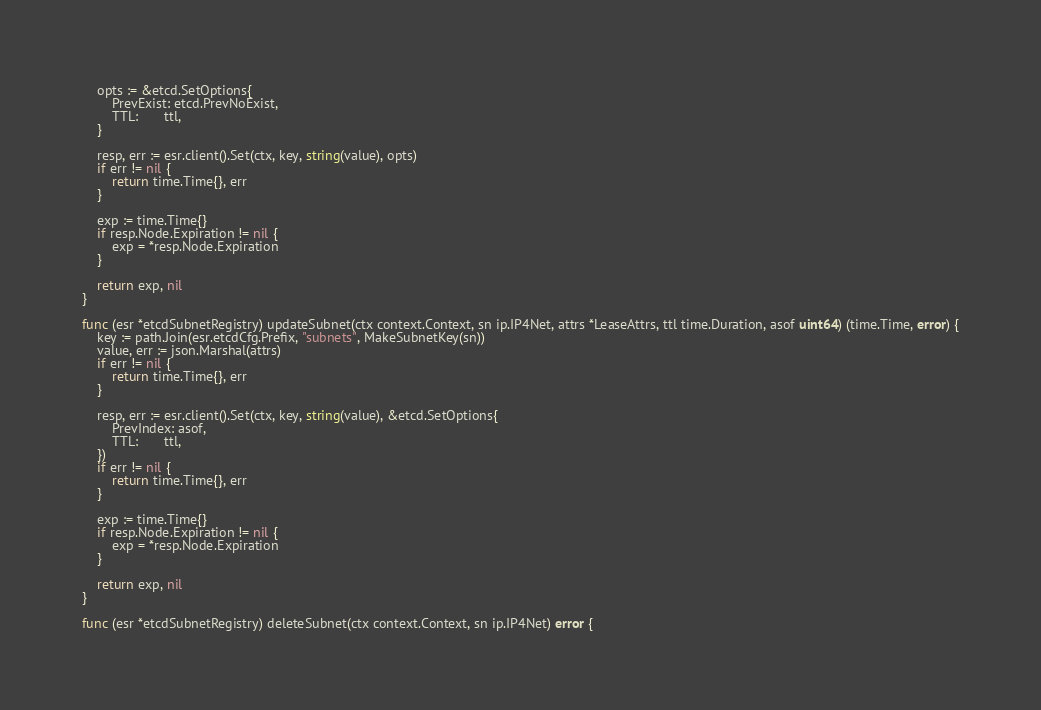<code> <loc_0><loc_0><loc_500><loc_500><_Go_>	opts := &etcd.SetOptions{
		PrevExist: etcd.PrevNoExist,
		TTL:       ttl,
	}

	resp, err := esr.client().Set(ctx, key, string(value), opts)
	if err != nil {
		return time.Time{}, err
	}

	exp := time.Time{}
	if resp.Node.Expiration != nil {
		exp = *resp.Node.Expiration
	}

	return exp, nil
}

func (esr *etcdSubnetRegistry) updateSubnet(ctx context.Context, sn ip.IP4Net, attrs *LeaseAttrs, ttl time.Duration, asof uint64) (time.Time, error) {
	key := path.Join(esr.etcdCfg.Prefix, "subnets", MakeSubnetKey(sn))
	value, err := json.Marshal(attrs)
	if err != nil {
		return time.Time{}, err
	}

	resp, err := esr.client().Set(ctx, key, string(value), &etcd.SetOptions{
		PrevIndex: asof,
		TTL:       ttl,
	})
	if err != nil {
		return time.Time{}, err
	}

	exp := time.Time{}
	if resp.Node.Expiration != nil {
		exp = *resp.Node.Expiration
	}

	return exp, nil
}

func (esr *etcdSubnetRegistry) deleteSubnet(ctx context.Context, sn ip.IP4Net) error {</code> 